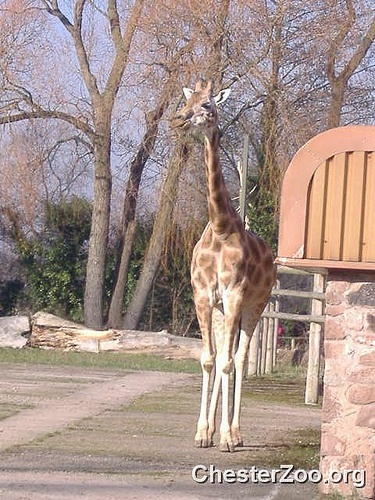Describe the objects in this image and their specific colors. I can see a giraffe in lavender, ivory, brown, tan, and gray tones in this image. 